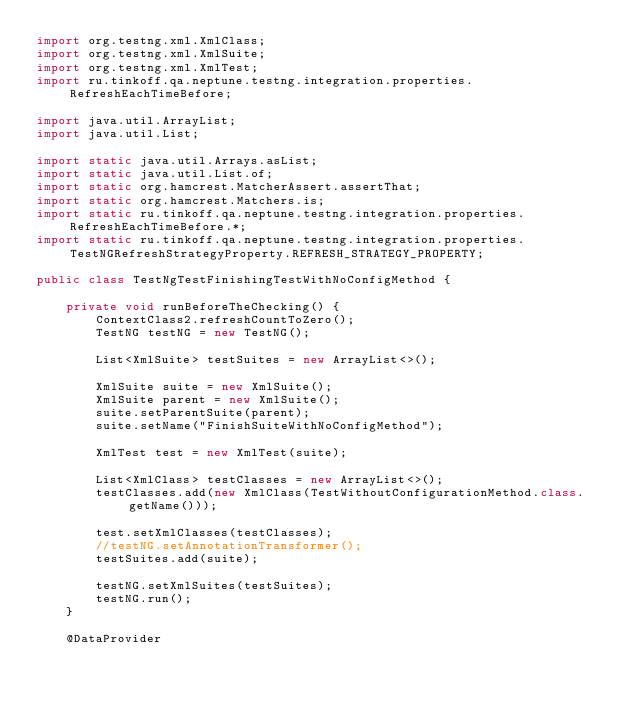<code> <loc_0><loc_0><loc_500><loc_500><_Java_>import org.testng.xml.XmlClass;
import org.testng.xml.XmlSuite;
import org.testng.xml.XmlTest;
import ru.tinkoff.qa.neptune.testng.integration.properties.RefreshEachTimeBefore;

import java.util.ArrayList;
import java.util.List;

import static java.util.Arrays.asList;
import static java.util.List.of;
import static org.hamcrest.MatcherAssert.assertThat;
import static org.hamcrest.Matchers.is;
import static ru.tinkoff.qa.neptune.testng.integration.properties.RefreshEachTimeBefore.*;
import static ru.tinkoff.qa.neptune.testng.integration.properties.TestNGRefreshStrategyProperty.REFRESH_STRATEGY_PROPERTY;

public class TestNgTestFinishingTestWithNoConfigMethod {

    private void runBeforeTheChecking() {
        ContextClass2.refreshCountToZero();
        TestNG testNG = new TestNG();

        List<XmlSuite> testSuites = new ArrayList<>();

        XmlSuite suite = new XmlSuite();
        XmlSuite parent = new XmlSuite();
        suite.setParentSuite(parent);
        suite.setName("FinishSuiteWithNoConfigMethod");

        XmlTest test = new XmlTest(suite);

        List<XmlClass> testClasses = new ArrayList<>();
        testClasses.add(new XmlClass(TestWithoutConfigurationMethod.class.getName()));

        test.setXmlClasses(testClasses);
        //testNG.setAnnotationTransformer();
        testSuites.add(suite);

        testNG.setXmlSuites(testSuites);
        testNG.run();
    }

    @DataProvider</code> 